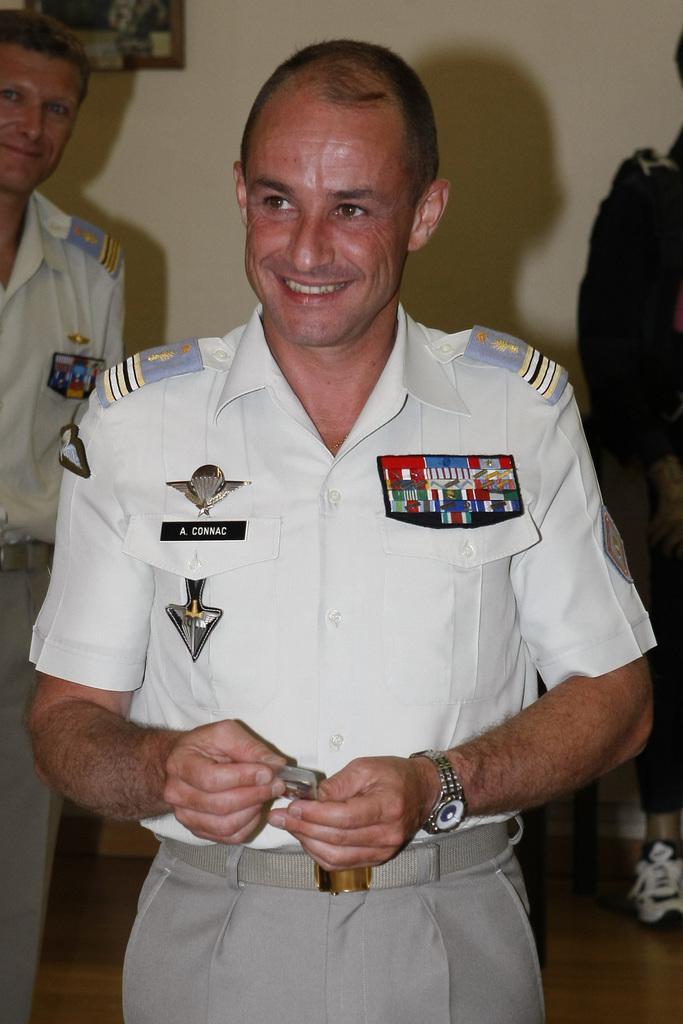Describe this image in one or two sentences. In this image, we can see a person is smiling and holding some object. Background there is a wall. Here we can see two people on the floor. Top of the image, we can see a photo frame. 